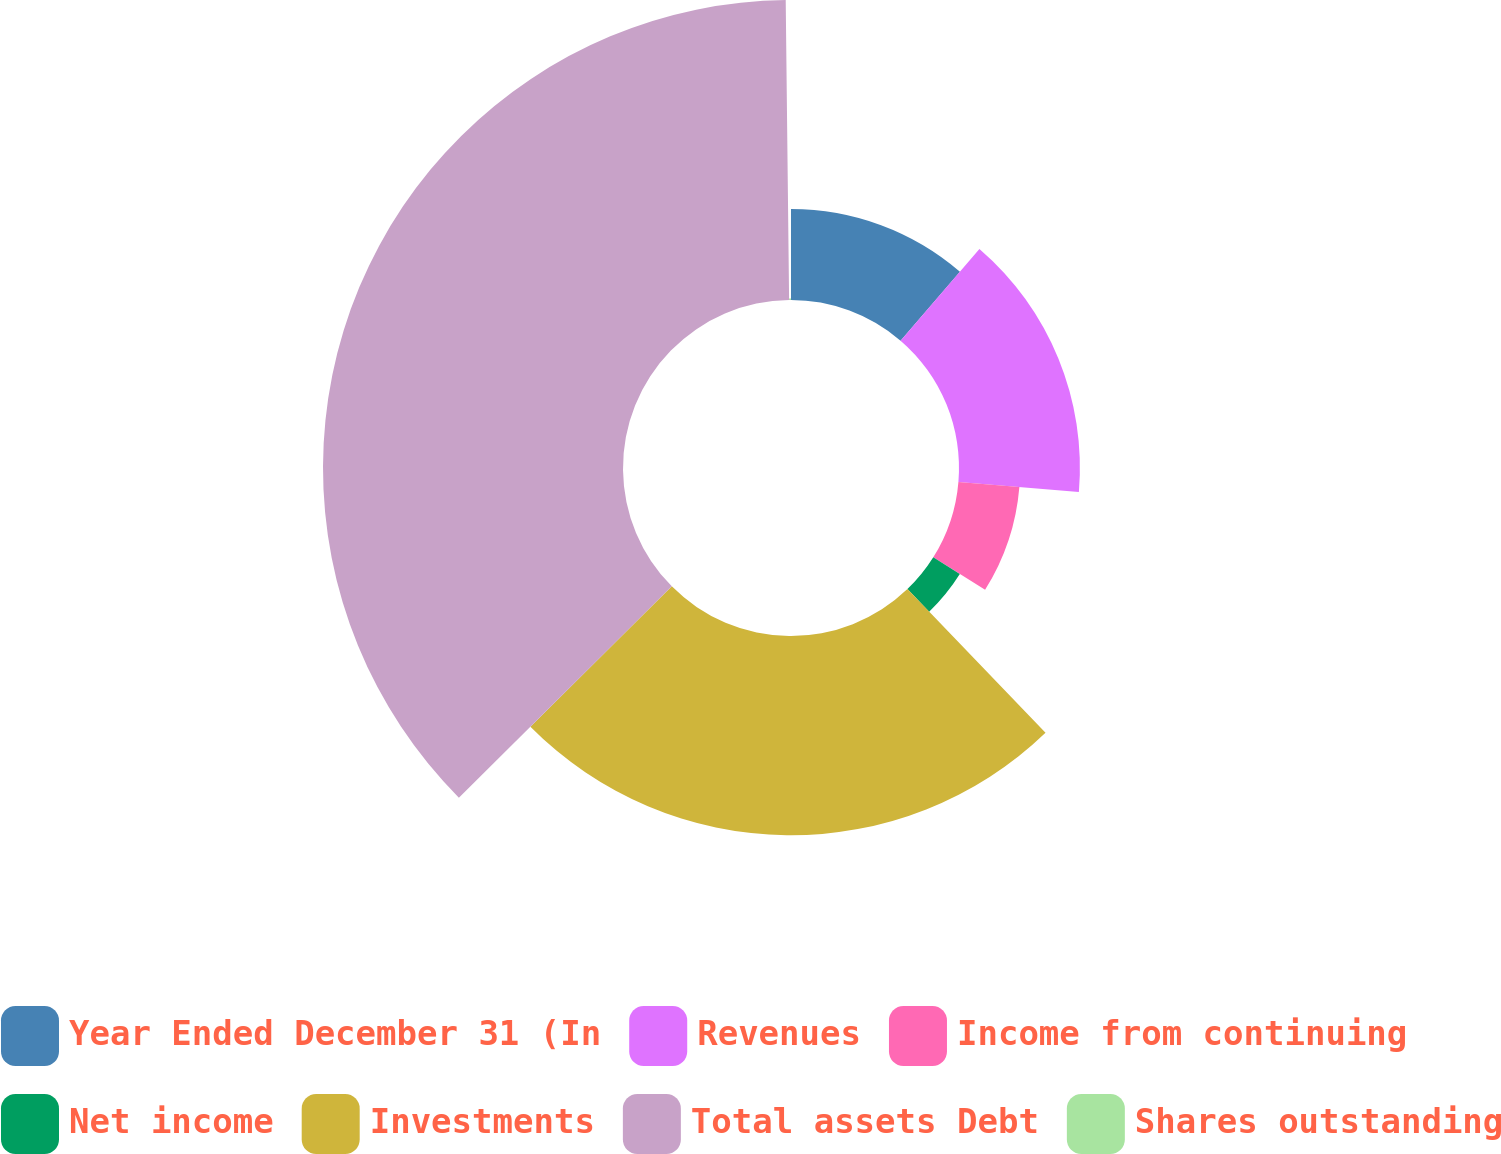<chart> <loc_0><loc_0><loc_500><loc_500><pie_chart><fcel>Year Ended December 31 (In<fcel>Revenues<fcel>Income from continuing<fcel>Net income<fcel>Investments<fcel>Total assets Debt<fcel>Shares outstanding<nl><fcel>11.31%<fcel>15.02%<fcel>7.6%<fcel>3.89%<fcel>24.75%<fcel>37.27%<fcel>0.18%<nl></chart> 